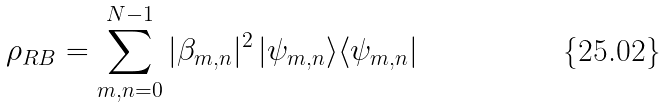<formula> <loc_0><loc_0><loc_500><loc_500>\rho _ { R B } = \sum _ { m , n = 0 } ^ { N - 1 } | \beta _ { m , n } | ^ { 2 } \, | \psi _ { m , n } \rangle \langle \psi _ { m , n } |</formula> 